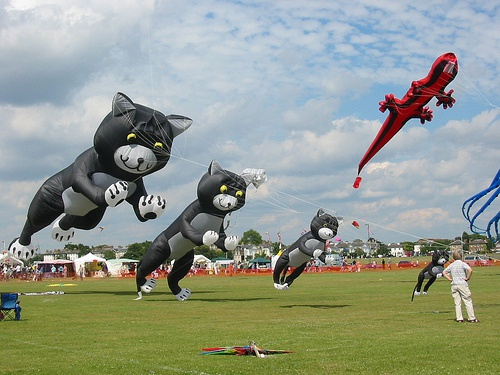Describe the objects in this image and their specific colors. I can see kite in lightgray, black, gray, and darkgray tones, kite in lightgray, black, gray, and darkgray tones, kite in lightgray, maroon, black, and brown tones, kite in lightgray, gray, black, and darkgray tones, and kite in lightgray, darkgray, navy, and blue tones in this image. 